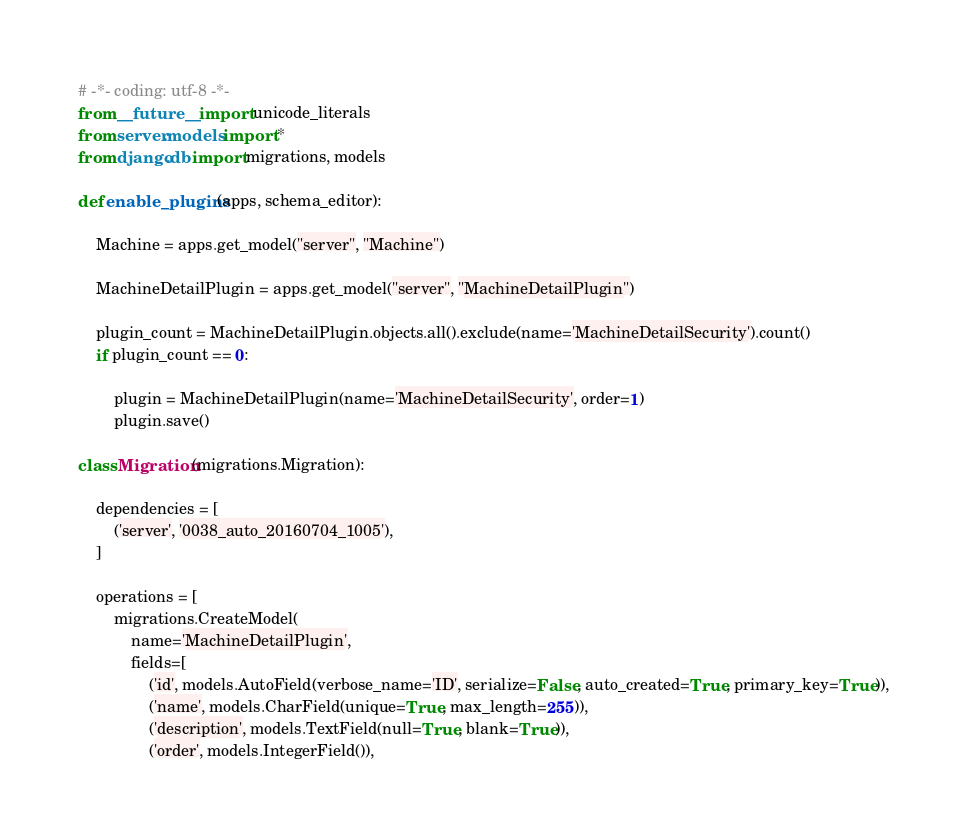Convert code to text. <code><loc_0><loc_0><loc_500><loc_500><_Python_># -*- coding: utf-8 -*-
from __future__ import unicode_literals
from server.models import *
from django.db import migrations, models

def enable_plugins(apps, schema_editor):

    Machine = apps.get_model("server", "Machine")

    MachineDetailPlugin = apps.get_model("server", "MachineDetailPlugin")

    plugin_count = MachineDetailPlugin.objects.all().exclude(name='MachineDetailSecurity').count()
    if plugin_count == 0:

        plugin = MachineDetailPlugin(name='MachineDetailSecurity', order=1)
        plugin.save()

class Migration(migrations.Migration):

    dependencies = [
        ('server', '0038_auto_20160704_1005'),
    ]

    operations = [
        migrations.CreateModel(
            name='MachineDetailPlugin',
            fields=[
                ('id', models.AutoField(verbose_name='ID', serialize=False, auto_created=True, primary_key=True)),
                ('name', models.CharField(unique=True, max_length=255)),
                ('description', models.TextField(null=True, blank=True)),
                ('order', models.IntegerField()),</code> 